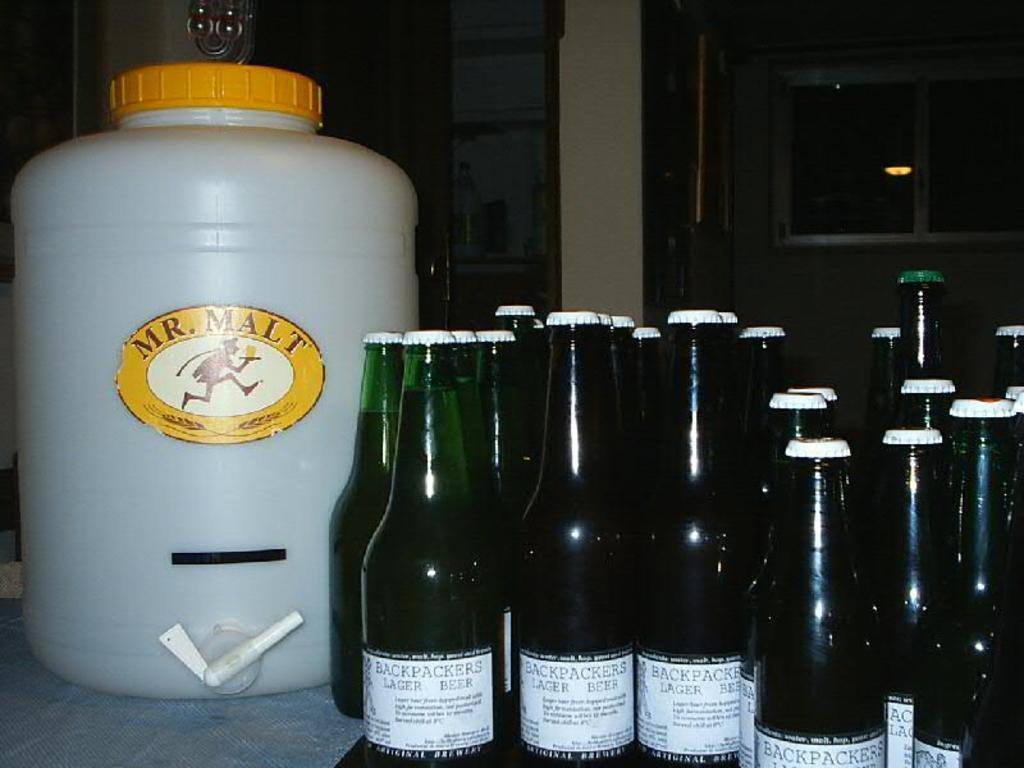Provide a one-sentence caption for the provided image. Beer bottles of Back Packers with larger can of Mr. Malt branded. 